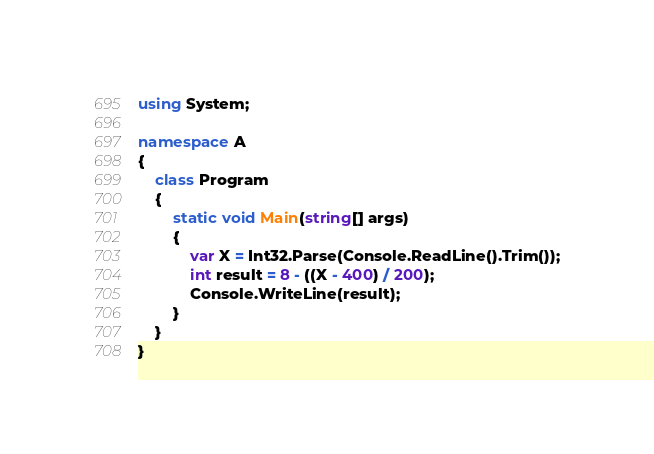<code> <loc_0><loc_0><loc_500><loc_500><_C#_>using System;

namespace A
{
    class Program
    {
        static void Main(string[] args)
        {
            var X = Int32.Parse(Console.ReadLine().Trim());
            int result = 8 - ((X - 400) / 200);
            Console.WriteLine(result);
        }
    }
}
</code> 